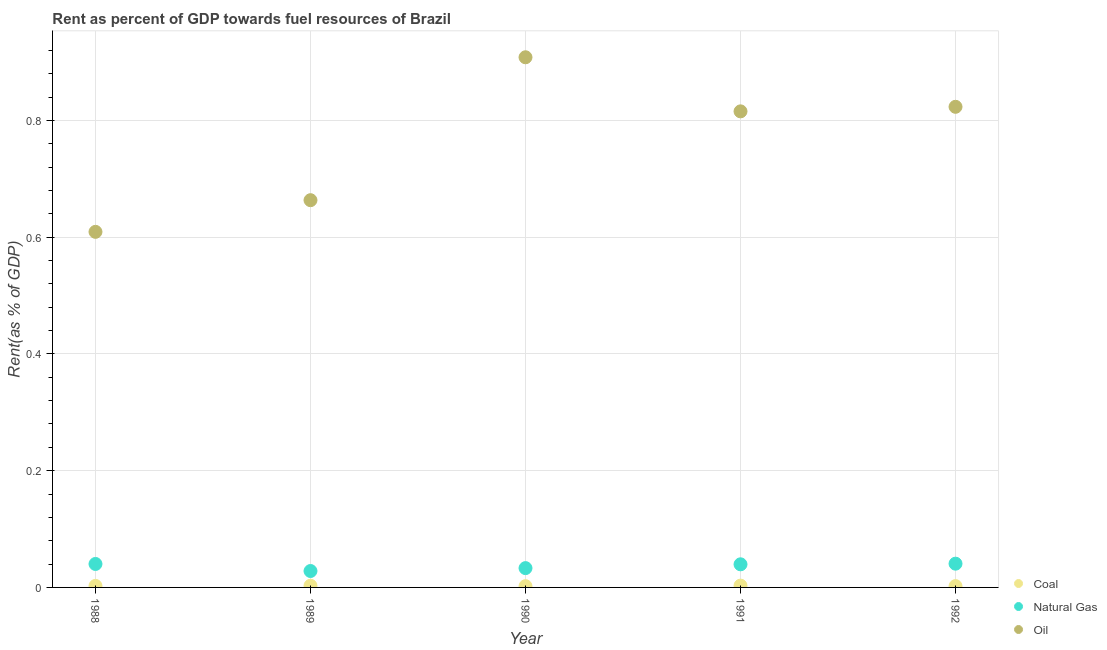How many different coloured dotlines are there?
Offer a terse response. 3. Is the number of dotlines equal to the number of legend labels?
Your answer should be very brief. Yes. What is the rent towards oil in 1988?
Give a very brief answer. 0.61. Across all years, what is the maximum rent towards natural gas?
Provide a short and direct response. 0.04. Across all years, what is the minimum rent towards oil?
Provide a succinct answer. 0.61. In which year was the rent towards coal maximum?
Your response must be concise. 1991. What is the total rent towards oil in the graph?
Provide a short and direct response. 3.82. What is the difference between the rent towards oil in 1988 and that in 1989?
Make the answer very short. -0.05. What is the difference between the rent towards coal in 1988 and the rent towards natural gas in 1990?
Make the answer very short. -0.03. What is the average rent towards oil per year?
Your answer should be compact. 0.76. In the year 1992, what is the difference between the rent towards oil and rent towards natural gas?
Provide a succinct answer. 0.78. In how many years, is the rent towards coal greater than 0.44 %?
Give a very brief answer. 0. What is the ratio of the rent towards natural gas in 1989 to that in 1991?
Keep it short and to the point. 0.71. Is the difference between the rent towards oil in 1989 and 1990 greater than the difference between the rent towards natural gas in 1989 and 1990?
Your answer should be compact. No. What is the difference between the highest and the second highest rent towards natural gas?
Offer a terse response. 0. What is the difference between the highest and the lowest rent towards oil?
Your response must be concise. 0.3. In how many years, is the rent towards oil greater than the average rent towards oil taken over all years?
Keep it short and to the point. 3. Is the sum of the rent towards natural gas in 1988 and 1989 greater than the maximum rent towards coal across all years?
Provide a short and direct response. Yes. Is it the case that in every year, the sum of the rent towards coal and rent towards natural gas is greater than the rent towards oil?
Your answer should be compact. No. Is the rent towards oil strictly greater than the rent towards coal over the years?
Offer a terse response. Yes. How many years are there in the graph?
Provide a short and direct response. 5. What is the difference between two consecutive major ticks on the Y-axis?
Give a very brief answer. 0.2. Where does the legend appear in the graph?
Keep it short and to the point. Bottom right. How many legend labels are there?
Your answer should be very brief. 3. What is the title of the graph?
Make the answer very short. Rent as percent of GDP towards fuel resources of Brazil. What is the label or title of the X-axis?
Offer a very short reply. Year. What is the label or title of the Y-axis?
Provide a succinct answer. Rent(as % of GDP). What is the Rent(as % of GDP) of Coal in 1988?
Provide a succinct answer. 0. What is the Rent(as % of GDP) in Natural Gas in 1988?
Your response must be concise. 0.04. What is the Rent(as % of GDP) in Oil in 1988?
Your answer should be compact. 0.61. What is the Rent(as % of GDP) in Coal in 1989?
Provide a short and direct response. 0. What is the Rent(as % of GDP) in Natural Gas in 1989?
Ensure brevity in your answer.  0.03. What is the Rent(as % of GDP) of Oil in 1989?
Give a very brief answer. 0.66. What is the Rent(as % of GDP) of Coal in 1990?
Make the answer very short. 0. What is the Rent(as % of GDP) in Natural Gas in 1990?
Keep it short and to the point. 0.03. What is the Rent(as % of GDP) of Oil in 1990?
Make the answer very short. 0.91. What is the Rent(as % of GDP) in Coal in 1991?
Provide a succinct answer. 0. What is the Rent(as % of GDP) of Natural Gas in 1991?
Offer a terse response. 0.04. What is the Rent(as % of GDP) in Oil in 1991?
Ensure brevity in your answer.  0.82. What is the Rent(as % of GDP) in Coal in 1992?
Your answer should be very brief. 0. What is the Rent(as % of GDP) of Natural Gas in 1992?
Offer a very short reply. 0.04. What is the Rent(as % of GDP) of Oil in 1992?
Provide a short and direct response. 0.82. Across all years, what is the maximum Rent(as % of GDP) of Coal?
Provide a succinct answer. 0. Across all years, what is the maximum Rent(as % of GDP) of Natural Gas?
Your answer should be compact. 0.04. Across all years, what is the maximum Rent(as % of GDP) of Oil?
Provide a short and direct response. 0.91. Across all years, what is the minimum Rent(as % of GDP) in Coal?
Offer a very short reply. 0. Across all years, what is the minimum Rent(as % of GDP) of Natural Gas?
Your response must be concise. 0.03. Across all years, what is the minimum Rent(as % of GDP) in Oil?
Offer a very short reply. 0.61. What is the total Rent(as % of GDP) of Coal in the graph?
Provide a succinct answer. 0.01. What is the total Rent(as % of GDP) in Natural Gas in the graph?
Make the answer very short. 0.18. What is the total Rent(as % of GDP) of Oil in the graph?
Offer a terse response. 3.82. What is the difference between the Rent(as % of GDP) in Coal in 1988 and that in 1989?
Your answer should be compact. -0. What is the difference between the Rent(as % of GDP) in Natural Gas in 1988 and that in 1989?
Give a very brief answer. 0.01. What is the difference between the Rent(as % of GDP) of Oil in 1988 and that in 1989?
Your response must be concise. -0.05. What is the difference between the Rent(as % of GDP) of Natural Gas in 1988 and that in 1990?
Provide a short and direct response. 0.01. What is the difference between the Rent(as % of GDP) in Oil in 1988 and that in 1990?
Your response must be concise. -0.3. What is the difference between the Rent(as % of GDP) of Coal in 1988 and that in 1991?
Your response must be concise. -0. What is the difference between the Rent(as % of GDP) in Natural Gas in 1988 and that in 1991?
Your answer should be compact. 0. What is the difference between the Rent(as % of GDP) of Oil in 1988 and that in 1991?
Keep it short and to the point. -0.21. What is the difference between the Rent(as % of GDP) of Coal in 1988 and that in 1992?
Offer a terse response. 0. What is the difference between the Rent(as % of GDP) of Natural Gas in 1988 and that in 1992?
Your response must be concise. -0. What is the difference between the Rent(as % of GDP) in Oil in 1988 and that in 1992?
Your response must be concise. -0.21. What is the difference between the Rent(as % of GDP) of Coal in 1989 and that in 1990?
Offer a terse response. 0. What is the difference between the Rent(as % of GDP) in Natural Gas in 1989 and that in 1990?
Your answer should be very brief. -0.01. What is the difference between the Rent(as % of GDP) in Oil in 1989 and that in 1990?
Ensure brevity in your answer.  -0.24. What is the difference between the Rent(as % of GDP) of Coal in 1989 and that in 1991?
Provide a succinct answer. -0. What is the difference between the Rent(as % of GDP) of Natural Gas in 1989 and that in 1991?
Your response must be concise. -0.01. What is the difference between the Rent(as % of GDP) of Oil in 1989 and that in 1991?
Provide a short and direct response. -0.15. What is the difference between the Rent(as % of GDP) of Coal in 1989 and that in 1992?
Provide a succinct answer. 0. What is the difference between the Rent(as % of GDP) of Natural Gas in 1989 and that in 1992?
Your response must be concise. -0.01. What is the difference between the Rent(as % of GDP) in Oil in 1989 and that in 1992?
Keep it short and to the point. -0.16. What is the difference between the Rent(as % of GDP) of Coal in 1990 and that in 1991?
Provide a succinct answer. -0. What is the difference between the Rent(as % of GDP) in Natural Gas in 1990 and that in 1991?
Your response must be concise. -0.01. What is the difference between the Rent(as % of GDP) in Oil in 1990 and that in 1991?
Provide a short and direct response. 0.09. What is the difference between the Rent(as % of GDP) of Coal in 1990 and that in 1992?
Keep it short and to the point. -0. What is the difference between the Rent(as % of GDP) of Natural Gas in 1990 and that in 1992?
Make the answer very short. -0.01. What is the difference between the Rent(as % of GDP) in Oil in 1990 and that in 1992?
Ensure brevity in your answer.  0.08. What is the difference between the Rent(as % of GDP) of Coal in 1991 and that in 1992?
Your answer should be very brief. 0. What is the difference between the Rent(as % of GDP) in Natural Gas in 1991 and that in 1992?
Offer a terse response. -0. What is the difference between the Rent(as % of GDP) in Oil in 1991 and that in 1992?
Provide a short and direct response. -0.01. What is the difference between the Rent(as % of GDP) in Coal in 1988 and the Rent(as % of GDP) in Natural Gas in 1989?
Provide a succinct answer. -0.03. What is the difference between the Rent(as % of GDP) of Coal in 1988 and the Rent(as % of GDP) of Oil in 1989?
Make the answer very short. -0.66. What is the difference between the Rent(as % of GDP) of Natural Gas in 1988 and the Rent(as % of GDP) of Oil in 1989?
Your answer should be compact. -0.62. What is the difference between the Rent(as % of GDP) of Coal in 1988 and the Rent(as % of GDP) of Natural Gas in 1990?
Provide a short and direct response. -0.03. What is the difference between the Rent(as % of GDP) in Coal in 1988 and the Rent(as % of GDP) in Oil in 1990?
Provide a succinct answer. -0.91. What is the difference between the Rent(as % of GDP) of Natural Gas in 1988 and the Rent(as % of GDP) of Oil in 1990?
Provide a succinct answer. -0.87. What is the difference between the Rent(as % of GDP) in Coal in 1988 and the Rent(as % of GDP) in Natural Gas in 1991?
Offer a very short reply. -0.04. What is the difference between the Rent(as % of GDP) in Coal in 1988 and the Rent(as % of GDP) in Oil in 1991?
Give a very brief answer. -0.81. What is the difference between the Rent(as % of GDP) of Natural Gas in 1988 and the Rent(as % of GDP) of Oil in 1991?
Your response must be concise. -0.78. What is the difference between the Rent(as % of GDP) of Coal in 1988 and the Rent(as % of GDP) of Natural Gas in 1992?
Give a very brief answer. -0.04. What is the difference between the Rent(as % of GDP) in Coal in 1988 and the Rent(as % of GDP) in Oil in 1992?
Your answer should be compact. -0.82. What is the difference between the Rent(as % of GDP) of Natural Gas in 1988 and the Rent(as % of GDP) of Oil in 1992?
Your response must be concise. -0.78. What is the difference between the Rent(as % of GDP) of Coal in 1989 and the Rent(as % of GDP) of Natural Gas in 1990?
Make the answer very short. -0.03. What is the difference between the Rent(as % of GDP) of Coal in 1989 and the Rent(as % of GDP) of Oil in 1990?
Keep it short and to the point. -0.91. What is the difference between the Rent(as % of GDP) in Natural Gas in 1989 and the Rent(as % of GDP) in Oil in 1990?
Provide a short and direct response. -0.88. What is the difference between the Rent(as % of GDP) in Coal in 1989 and the Rent(as % of GDP) in Natural Gas in 1991?
Provide a short and direct response. -0.04. What is the difference between the Rent(as % of GDP) in Coal in 1989 and the Rent(as % of GDP) in Oil in 1991?
Offer a very short reply. -0.81. What is the difference between the Rent(as % of GDP) in Natural Gas in 1989 and the Rent(as % of GDP) in Oil in 1991?
Your answer should be compact. -0.79. What is the difference between the Rent(as % of GDP) of Coal in 1989 and the Rent(as % of GDP) of Natural Gas in 1992?
Provide a succinct answer. -0.04. What is the difference between the Rent(as % of GDP) of Coal in 1989 and the Rent(as % of GDP) of Oil in 1992?
Provide a short and direct response. -0.82. What is the difference between the Rent(as % of GDP) in Natural Gas in 1989 and the Rent(as % of GDP) in Oil in 1992?
Ensure brevity in your answer.  -0.8. What is the difference between the Rent(as % of GDP) in Coal in 1990 and the Rent(as % of GDP) in Natural Gas in 1991?
Make the answer very short. -0.04. What is the difference between the Rent(as % of GDP) in Coal in 1990 and the Rent(as % of GDP) in Oil in 1991?
Your response must be concise. -0.81. What is the difference between the Rent(as % of GDP) of Natural Gas in 1990 and the Rent(as % of GDP) of Oil in 1991?
Provide a succinct answer. -0.78. What is the difference between the Rent(as % of GDP) of Coal in 1990 and the Rent(as % of GDP) of Natural Gas in 1992?
Offer a terse response. -0.04. What is the difference between the Rent(as % of GDP) of Coal in 1990 and the Rent(as % of GDP) of Oil in 1992?
Offer a very short reply. -0.82. What is the difference between the Rent(as % of GDP) in Natural Gas in 1990 and the Rent(as % of GDP) in Oil in 1992?
Provide a succinct answer. -0.79. What is the difference between the Rent(as % of GDP) in Coal in 1991 and the Rent(as % of GDP) in Natural Gas in 1992?
Provide a short and direct response. -0.04. What is the difference between the Rent(as % of GDP) in Coal in 1991 and the Rent(as % of GDP) in Oil in 1992?
Provide a succinct answer. -0.82. What is the difference between the Rent(as % of GDP) of Natural Gas in 1991 and the Rent(as % of GDP) of Oil in 1992?
Provide a short and direct response. -0.78. What is the average Rent(as % of GDP) in Coal per year?
Provide a short and direct response. 0. What is the average Rent(as % of GDP) in Natural Gas per year?
Your answer should be compact. 0.04. What is the average Rent(as % of GDP) in Oil per year?
Give a very brief answer. 0.76. In the year 1988, what is the difference between the Rent(as % of GDP) of Coal and Rent(as % of GDP) of Natural Gas?
Your response must be concise. -0.04. In the year 1988, what is the difference between the Rent(as % of GDP) of Coal and Rent(as % of GDP) of Oil?
Provide a short and direct response. -0.61. In the year 1988, what is the difference between the Rent(as % of GDP) of Natural Gas and Rent(as % of GDP) of Oil?
Offer a very short reply. -0.57. In the year 1989, what is the difference between the Rent(as % of GDP) of Coal and Rent(as % of GDP) of Natural Gas?
Offer a terse response. -0.03. In the year 1989, what is the difference between the Rent(as % of GDP) in Coal and Rent(as % of GDP) in Oil?
Give a very brief answer. -0.66. In the year 1989, what is the difference between the Rent(as % of GDP) in Natural Gas and Rent(as % of GDP) in Oil?
Your response must be concise. -0.64. In the year 1990, what is the difference between the Rent(as % of GDP) in Coal and Rent(as % of GDP) in Natural Gas?
Your answer should be compact. -0.03. In the year 1990, what is the difference between the Rent(as % of GDP) in Coal and Rent(as % of GDP) in Oil?
Give a very brief answer. -0.91. In the year 1990, what is the difference between the Rent(as % of GDP) of Natural Gas and Rent(as % of GDP) of Oil?
Your answer should be compact. -0.88. In the year 1991, what is the difference between the Rent(as % of GDP) in Coal and Rent(as % of GDP) in Natural Gas?
Provide a short and direct response. -0.04. In the year 1991, what is the difference between the Rent(as % of GDP) of Coal and Rent(as % of GDP) of Oil?
Your answer should be compact. -0.81. In the year 1991, what is the difference between the Rent(as % of GDP) in Natural Gas and Rent(as % of GDP) in Oil?
Give a very brief answer. -0.78. In the year 1992, what is the difference between the Rent(as % of GDP) of Coal and Rent(as % of GDP) of Natural Gas?
Give a very brief answer. -0.04. In the year 1992, what is the difference between the Rent(as % of GDP) in Coal and Rent(as % of GDP) in Oil?
Give a very brief answer. -0.82. In the year 1992, what is the difference between the Rent(as % of GDP) of Natural Gas and Rent(as % of GDP) of Oil?
Keep it short and to the point. -0.78. What is the ratio of the Rent(as % of GDP) of Coal in 1988 to that in 1989?
Your response must be concise. 0.9. What is the ratio of the Rent(as % of GDP) of Natural Gas in 1988 to that in 1989?
Make the answer very short. 1.43. What is the ratio of the Rent(as % of GDP) of Oil in 1988 to that in 1989?
Your answer should be compact. 0.92. What is the ratio of the Rent(as % of GDP) in Coal in 1988 to that in 1990?
Give a very brief answer. 1.22. What is the ratio of the Rent(as % of GDP) in Natural Gas in 1988 to that in 1990?
Your response must be concise. 1.21. What is the ratio of the Rent(as % of GDP) of Oil in 1988 to that in 1990?
Provide a short and direct response. 0.67. What is the ratio of the Rent(as % of GDP) in Coal in 1988 to that in 1991?
Give a very brief answer. 0.86. What is the ratio of the Rent(as % of GDP) of Natural Gas in 1988 to that in 1991?
Make the answer very short. 1.01. What is the ratio of the Rent(as % of GDP) of Oil in 1988 to that in 1991?
Give a very brief answer. 0.75. What is the ratio of the Rent(as % of GDP) in Coal in 1988 to that in 1992?
Your answer should be compact. 1.15. What is the ratio of the Rent(as % of GDP) of Natural Gas in 1988 to that in 1992?
Keep it short and to the point. 0.99. What is the ratio of the Rent(as % of GDP) of Oil in 1988 to that in 1992?
Offer a very short reply. 0.74. What is the ratio of the Rent(as % of GDP) in Coal in 1989 to that in 1990?
Your response must be concise. 1.35. What is the ratio of the Rent(as % of GDP) in Natural Gas in 1989 to that in 1990?
Offer a very short reply. 0.85. What is the ratio of the Rent(as % of GDP) of Oil in 1989 to that in 1990?
Provide a succinct answer. 0.73. What is the ratio of the Rent(as % of GDP) in Coal in 1989 to that in 1991?
Your answer should be very brief. 0.95. What is the ratio of the Rent(as % of GDP) in Natural Gas in 1989 to that in 1991?
Provide a succinct answer. 0.71. What is the ratio of the Rent(as % of GDP) of Oil in 1989 to that in 1991?
Your answer should be very brief. 0.81. What is the ratio of the Rent(as % of GDP) in Coal in 1989 to that in 1992?
Offer a terse response. 1.28. What is the ratio of the Rent(as % of GDP) in Natural Gas in 1989 to that in 1992?
Give a very brief answer. 0.69. What is the ratio of the Rent(as % of GDP) in Oil in 1989 to that in 1992?
Make the answer very short. 0.81. What is the ratio of the Rent(as % of GDP) in Coal in 1990 to that in 1991?
Keep it short and to the point. 0.7. What is the ratio of the Rent(as % of GDP) of Natural Gas in 1990 to that in 1991?
Your answer should be compact. 0.84. What is the ratio of the Rent(as % of GDP) of Oil in 1990 to that in 1991?
Your answer should be very brief. 1.11. What is the ratio of the Rent(as % of GDP) in Coal in 1990 to that in 1992?
Make the answer very short. 0.95. What is the ratio of the Rent(as % of GDP) of Natural Gas in 1990 to that in 1992?
Make the answer very short. 0.81. What is the ratio of the Rent(as % of GDP) of Oil in 1990 to that in 1992?
Offer a terse response. 1.1. What is the ratio of the Rent(as % of GDP) in Coal in 1991 to that in 1992?
Ensure brevity in your answer.  1.34. What is the ratio of the Rent(as % of GDP) in Natural Gas in 1991 to that in 1992?
Offer a very short reply. 0.97. What is the ratio of the Rent(as % of GDP) in Oil in 1991 to that in 1992?
Give a very brief answer. 0.99. What is the difference between the highest and the second highest Rent(as % of GDP) of Coal?
Offer a very short reply. 0. What is the difference between the highest and the second highest Rent(as % of GDP) of Natural Gas?
Offer a very short reply. 0. What is the difference between the highest and the second highest Rent(as % of GDP) in Oil?
Offer a very short reply. 0.08. What is the difference between the highest and the lowest Rent(as % of GDP) of Coal?
Provide a succinct answer. 0. What is the difference between the highest and the lowest Rent(as % of GDP) in Natural Gas?
Your response must be concise. 0.01. What is the difference between the highest and the lowest Rent(as % of GDP) in Oil?
Your answer should be compact. 0.3. 